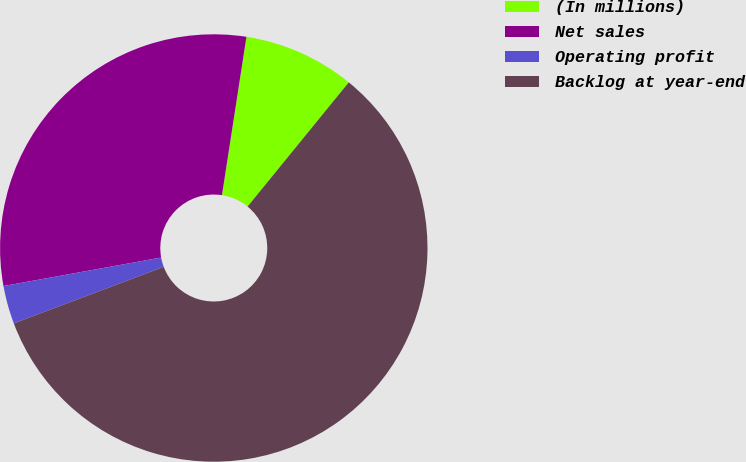<chart> <loc_0><loc_0><loc_500><loc_500><pie_chart><fcel>(In millions)<fcel>Net sales<fcel>Operating profit<fcel>Backlog at year-end<nl><fcel>8.44%<fcel>30.29%<fcel>2.89%<fcel>58.38%<nl></chart> 